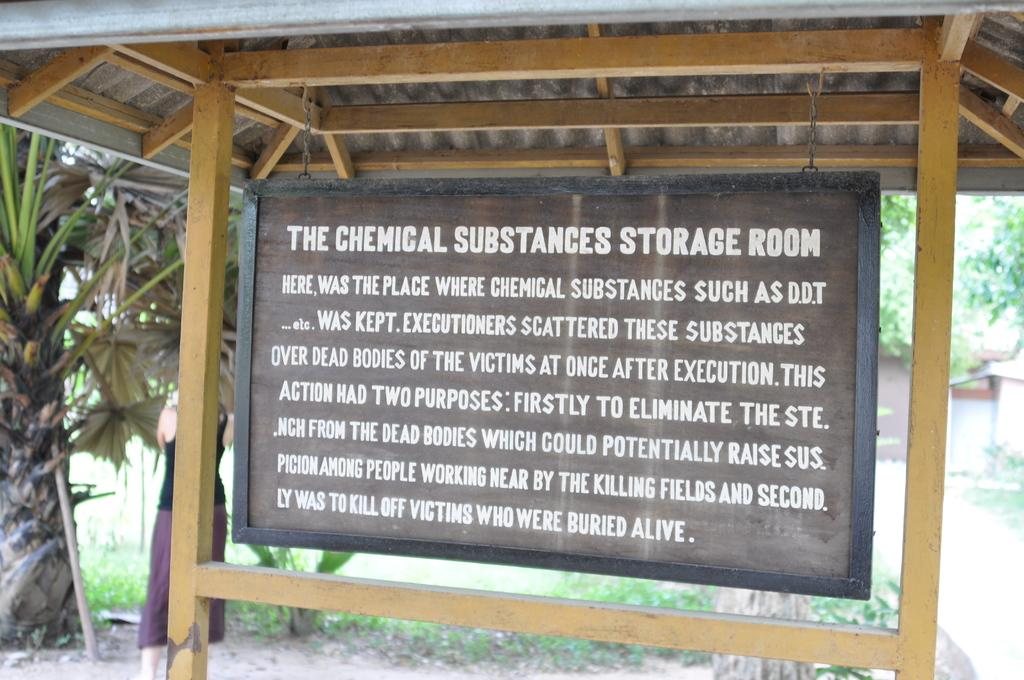What is the main object in the middle of the image? There is a board in the middle of the image. What can be seen on the board? There is text on the board. Who is present near the board? There is a person beside the board. What can be seen in the background of the image? There are trees in the background of the image. What type of shock can be seen on the person's feet in the image? There is no shock or mention of feet in the image; it only features a board with text, a person beside it, and trees in the background. 